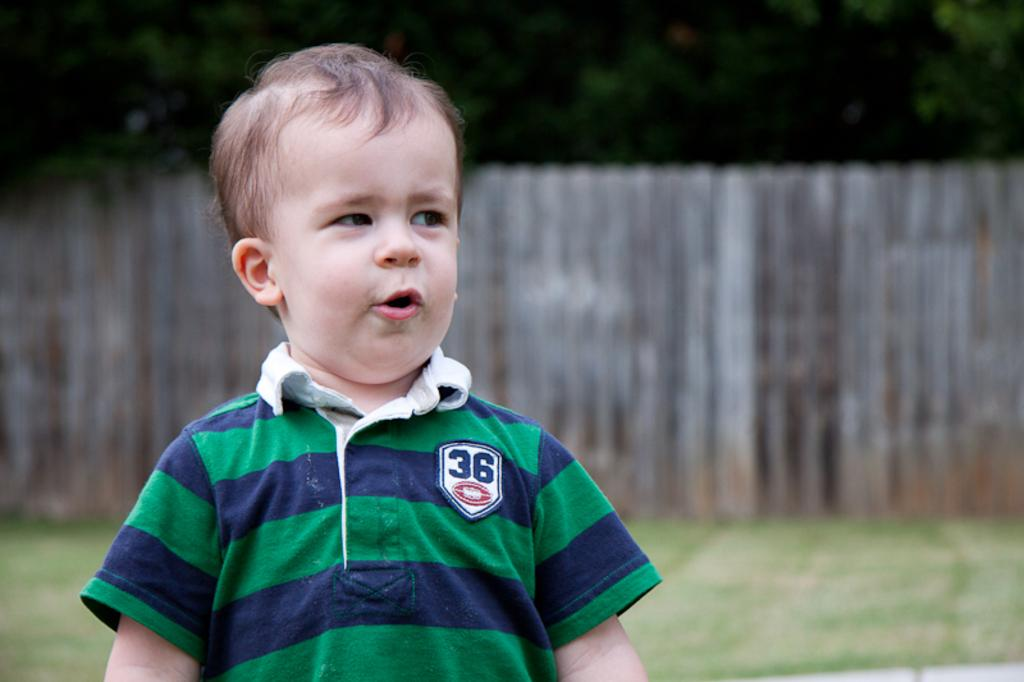<image>
Summarize the visual content of the image. Little boy standing outside with his mouth wide open 